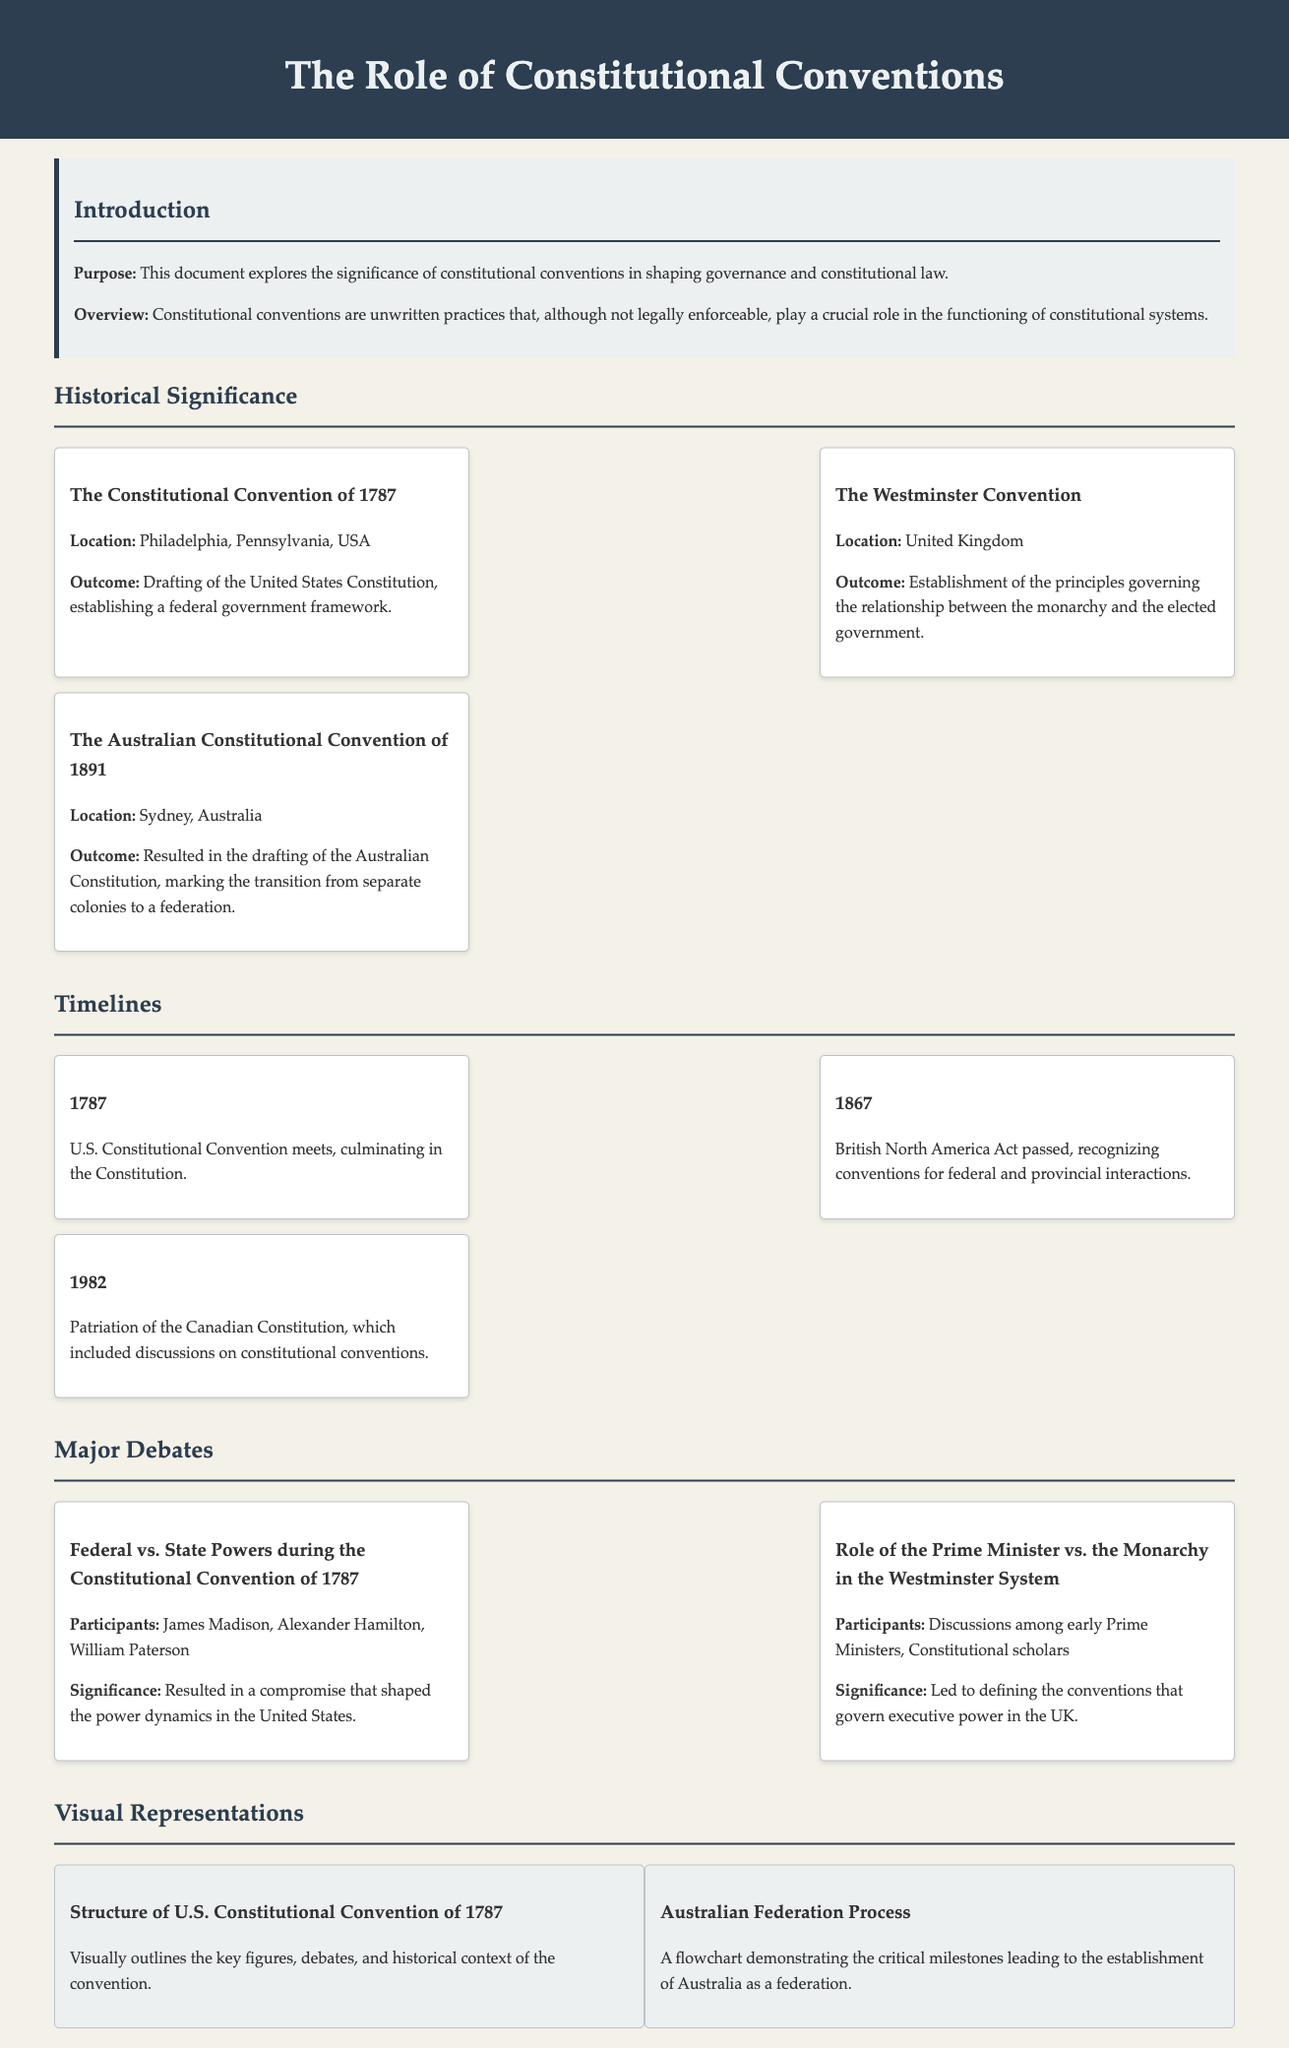What was the outcome of the Constitutional Convention of 1787? The outcome was the drafting of the United States Constitution, establishing a federal government framework.
Answer: Drafting of the United States Constitution Where was the Australian Constitutional Convention of 1891 held? The convention was held in Sydney, Australia.
Answer: Sydney, Australia Who were the participants in the debate regarding federal vs. state powers during the Constitutional Convention of 1787? The participants included James Madison, Alexander Hamilton, and William Paterson.
Answer: James Madison, Alexander Hamilton, William Paterson What year was the British North America Act passed? The British North America Act was passed in 1867.
Answer: 1867 What visual representation describes the key figures and debates of the U.S. Constitutional Convention of 1787? The visual representation is titled "Structure of U.S. Constitutional Convention of 1787."
Answer: Structure of U.S. Constitutional Convention of 1787 What key principle did the Westminster Convention establish? The convention established the principles governing the relationship between the monarchy and the elected government.
Answer: Relationship between the monarchy and the elected government What event does the timeline item for 1982 relate to? The timeline item for 1982 relates to the patriation of the Canadian Constitution, which included discussions on constitutional conventions.
Answer: Patriation of the Canadian Constitution Which convention marked Australia’s transition from separate colonies to a federation? The convention that marked this transition was the Australian Constitutional Convention of 1891.
Answer: Australian Constitutional Convention of 1891 